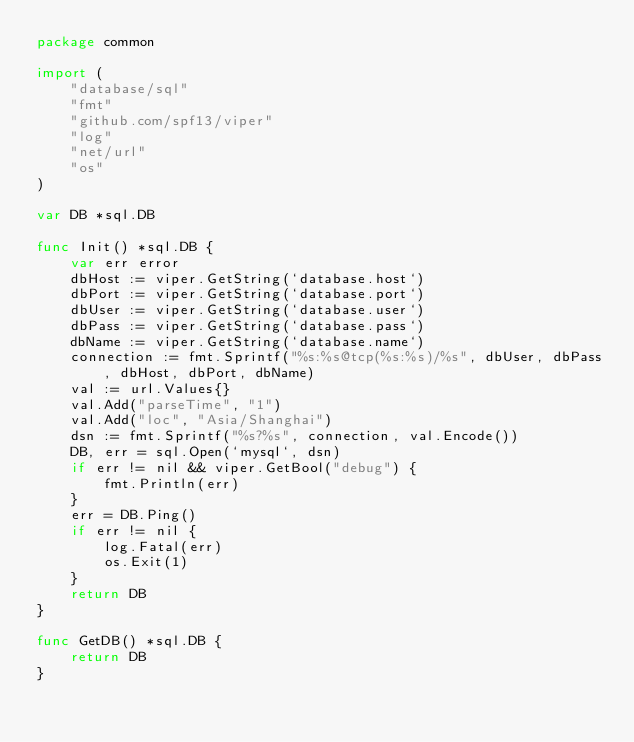Convert code to text. <code><loc_0><loc_0><loc_500><loc_500><_Go_>package common

import (
	"database/sql"
	"fmt"
	"github.com/spf13/viper"
	"log"
	"net/url"
	"os"
)

var DB *sql.DB

func Init() *sql.DB {
	var err error
	dbHost := viper.GetString(`database.host`)
	dbPort := viper.GetString(`database.port`)
	dbUser := viper.GetString(`database.user`)
	dbPass := viper.GetString(`database.pass`)
	dbName := viper.GetString(`database.name`)
	connection := fmt.Sprintf("%s:%s@tcp(%s:%s)/%s", dbUser, dbPass, dbHost, dbPort, dbName)
	val := url.Values{}
	val.Add("parseTime", "1")
	val.Add("loc", "Asia/Shanghai")
	dsn := fmt.Sprintf("%s?%s", connection, val.Encode())
	DB, err = sql.Open(`mysql`, dsn)
	if err != nil && viper.GetBool("debug") {
		fmt.Println(err)
	}
	err = DB.Ping()
	if err != nil {
		log.Fatal(err)
		os.Exit(1)
	}
	return DB
}

func GetDB() *sql.DB {
	return DB
}
</code> 